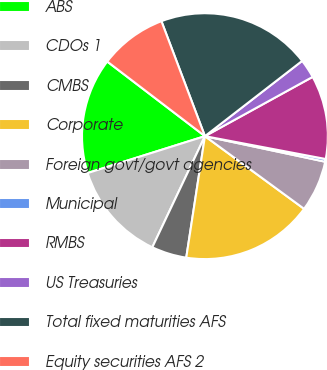Convert chart to OTSL. <chart><loc_0><loc_0><loc_500><loc_500><pie_chart><fcel>ABS<fcel>CDOs 1<fcel>CMBS<fcel>Corporate<fcel>Foreign govt/govt agencies<fcel>Municipal<fcel>RMBS<fcel>US Treasuries<fcel>Total fixed maturities AFS<fcel>Equity securities AFS 2<nl><fcel>15.23%<fcel>13.11%<fcel>4.61%<fcel>17.36%<fcel>6.73%<fcel>0.36%<fcel>10.98%<fcel>2.48%<fcel>20.27%<fcel>8.86%<nl></chart> 